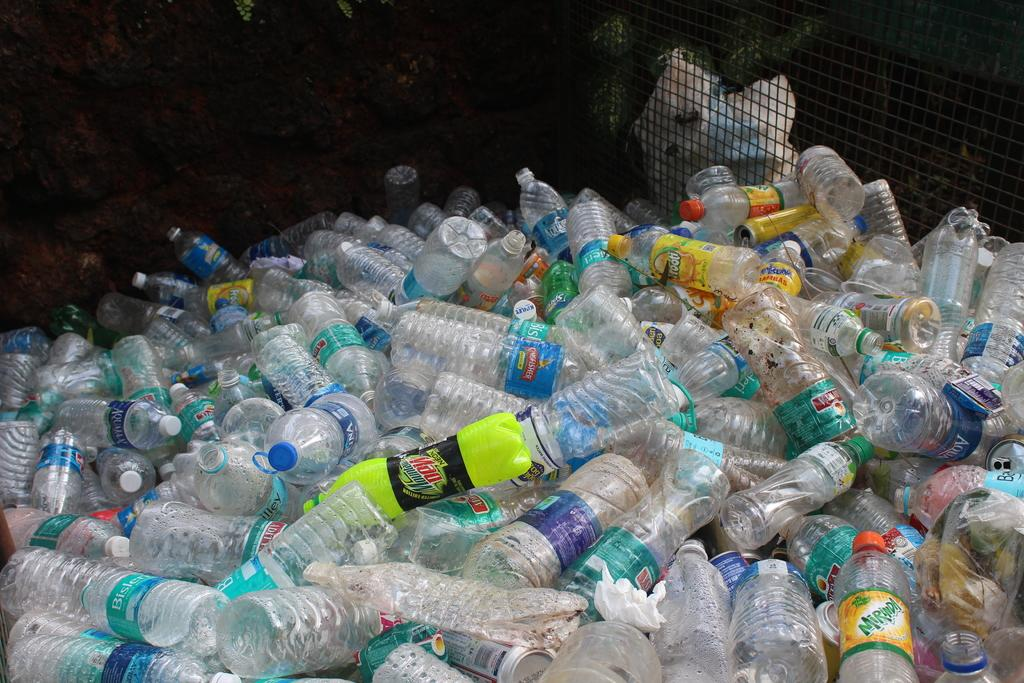<image>
Summarize the visual content of the image. A large pile of empty plastic bottle with a bottle of mountain Dew in the middle. 